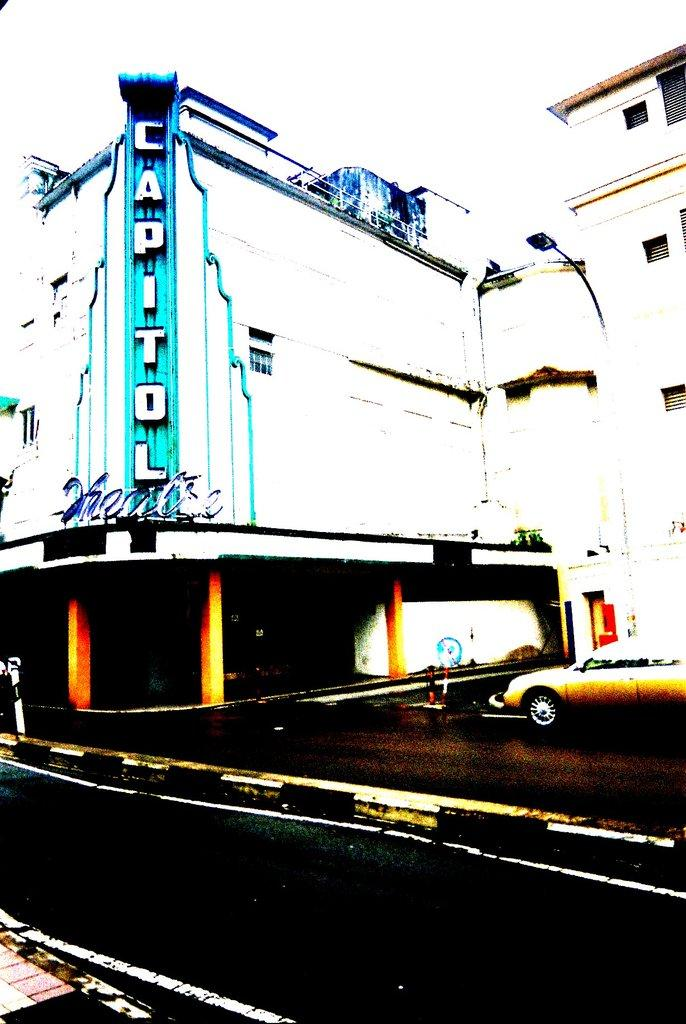What is the main feature of the image? There is a road in the image. What can be seen at the center of the image? There are buildings at the center of the image. Is there any vehicle visible in the image? Yes, a car is parked in front of the buildings. What can be seen in the background of the image? There is a sky visible in the background of the image. What type of dirt can be seen on the car's tires in the image? There is no dirt visible on the car's tires in the image. What kind of teeth can be seen on the buildings in the image? The buildings in the image do not have teeth. 